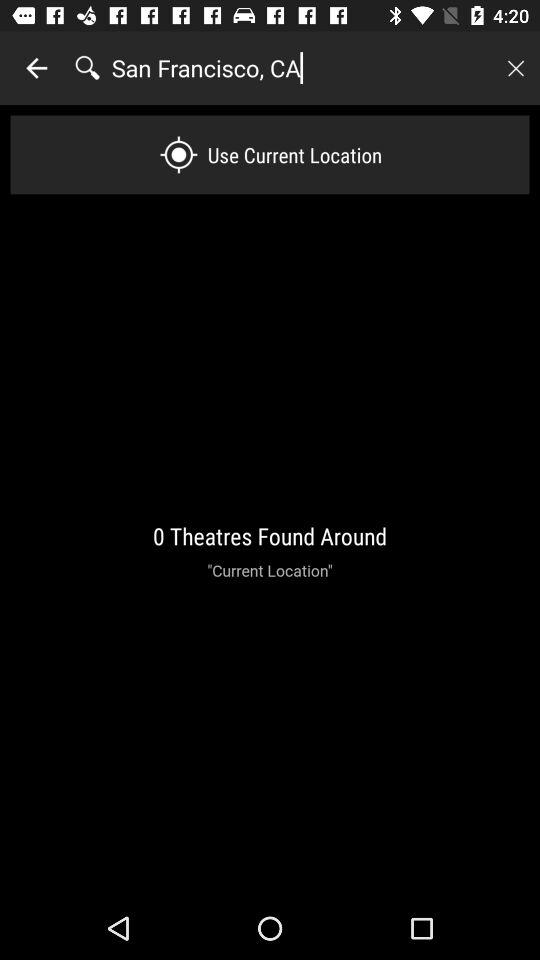How many theatres have been found around the current location?
Answer the question using a single word or phrase. 0 